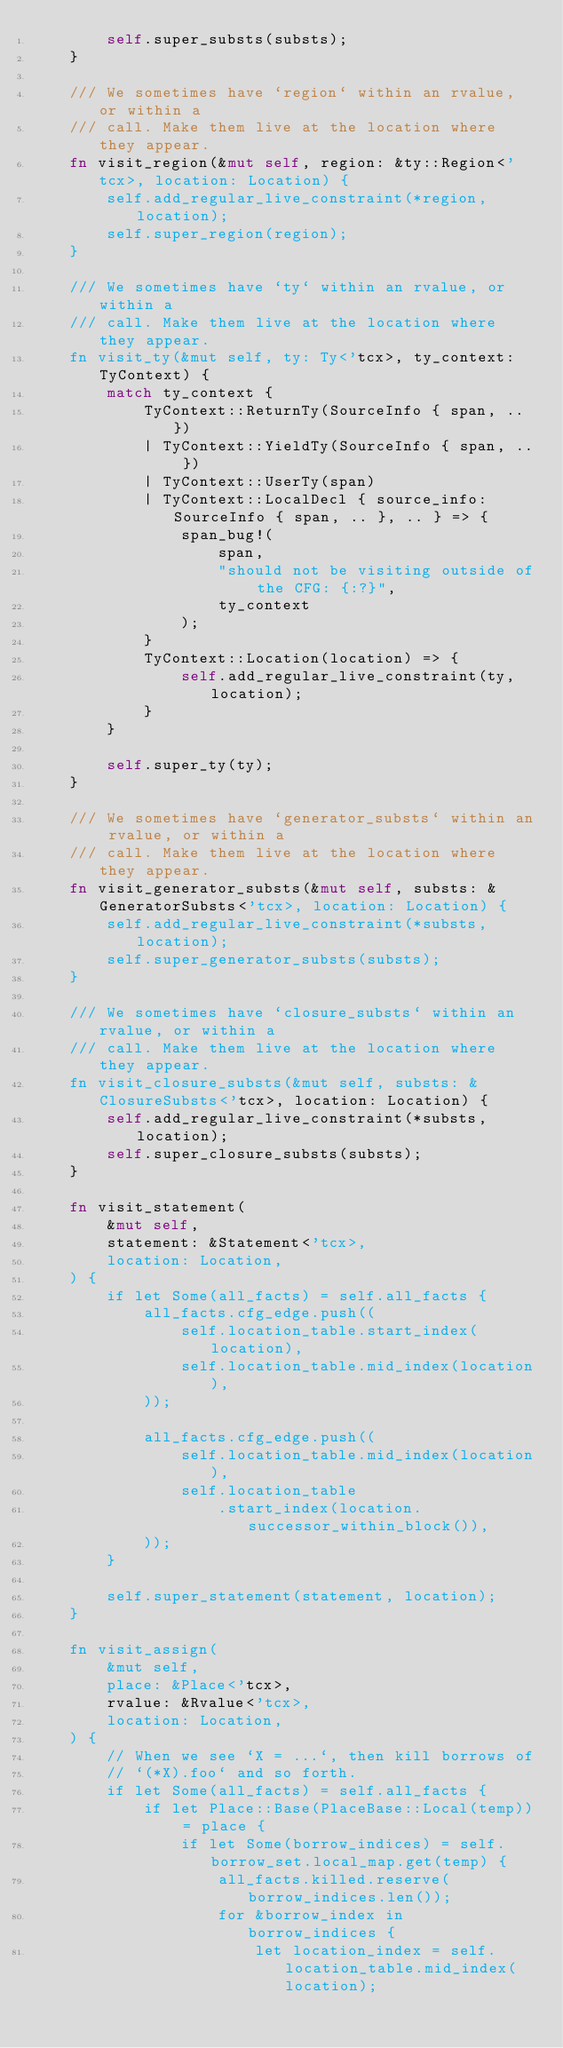<code> <loc_0><loc_0><loc_500><loc_500><_Rust_>        self.super_substs(substs);
    }

    /// We sometimes have `region` within an rvalue, or within a
    /// call. Make them live at the location where they appear.
    fn visit_region(&mut self, region: &ty::Region<'tcx>, location: Location) {
        self.add_regular_live_constraint(*region, location);
        self.super_region(region);
    }

    /// We sometimes have `ty` within an rvalue, or within a
    /// call. Make them live at the location where they appear.
    fn visit_ty(&mut self, ty: Ty<'tcx>, ty_context: TyContext) {
        match ty_context {
            TyContext::ReturnTy(SourceInfo { span, .. })
            | TyContext::YieldTy(SourceInfo { span, .. })
            | TyContext::UserTy(span)
            | TyContext::LocalDecl { source_info: SourceInfo { span, .. }, .. } => {
                span_bug!(
                    span,
                    "should not be visiting outside of the CFG: {:?}",
                    ty_context
                );
            }
            TyContext::Location(location) => {
                self.add_regular_live_constraint(ty, location);
            }
        }

        self.super_ty(ty);
    }

    /// We sometimes have `generator_substs` within an rvalue, or within a
    /// call. Make them live at the location where they appear.
    fn visit_generator_substs(&mut self, substs: &GeneratorSubsts<'tcx>, location: Location) {
        self.add_regular_live_constraint(*substs, location);
        self.super_generator_substs(substs);
    }

    /// We sometimes have `closure_substs` within an rvalue, or within a
    /// call. Make them live at the location where they appear.
    fn visit_closure_substs(&mut self, substs: &ClosureSubsts<'tcx>, location: Location) {
        self.add_regular_live_constraint(*substs, location);
        self.super_closure_substs(substs);
    }

    fn visit_statement(
        &mut self,
        statement: &Statement<'tcx>,
        location: Location,
    ) {
        if let Some(all_facts) = self.all_facts {
            all_facts.cfg_edge.push((
                self.location_table.start_index(location),
                self.location_table.mid_index(location),
            ));

            all_facts.cfg_edge.push((
                self.location_table.mid_index(location),
                self.location_table
                    .start_index(location.successor_within_block()),
            ));
        }

        self.super_statement(statement, location);
    }

    fn visit_assign(
        &mut self,
        place: &Place<'tcx>,
        rvalue: &Rvalue<'tcx>,
        location: Location,
    ) {
        // When we see `X = ...`, then kill borrows of
        // `(*X).foo` and so forth.
        if let Some(all_facts) = self.all_facts {
            if let Place::Base(PlaceBase::Local(temp)) = place {
                if let Some(borrow_indices) = self.borrow_set.local_map.get(temp) {
                    all_facts.killed.reserve(borrow_indices.len());
                    for &borrow_index in borrow_indices {
                        let location_index = self.location_table.mid_index(location);</code> 